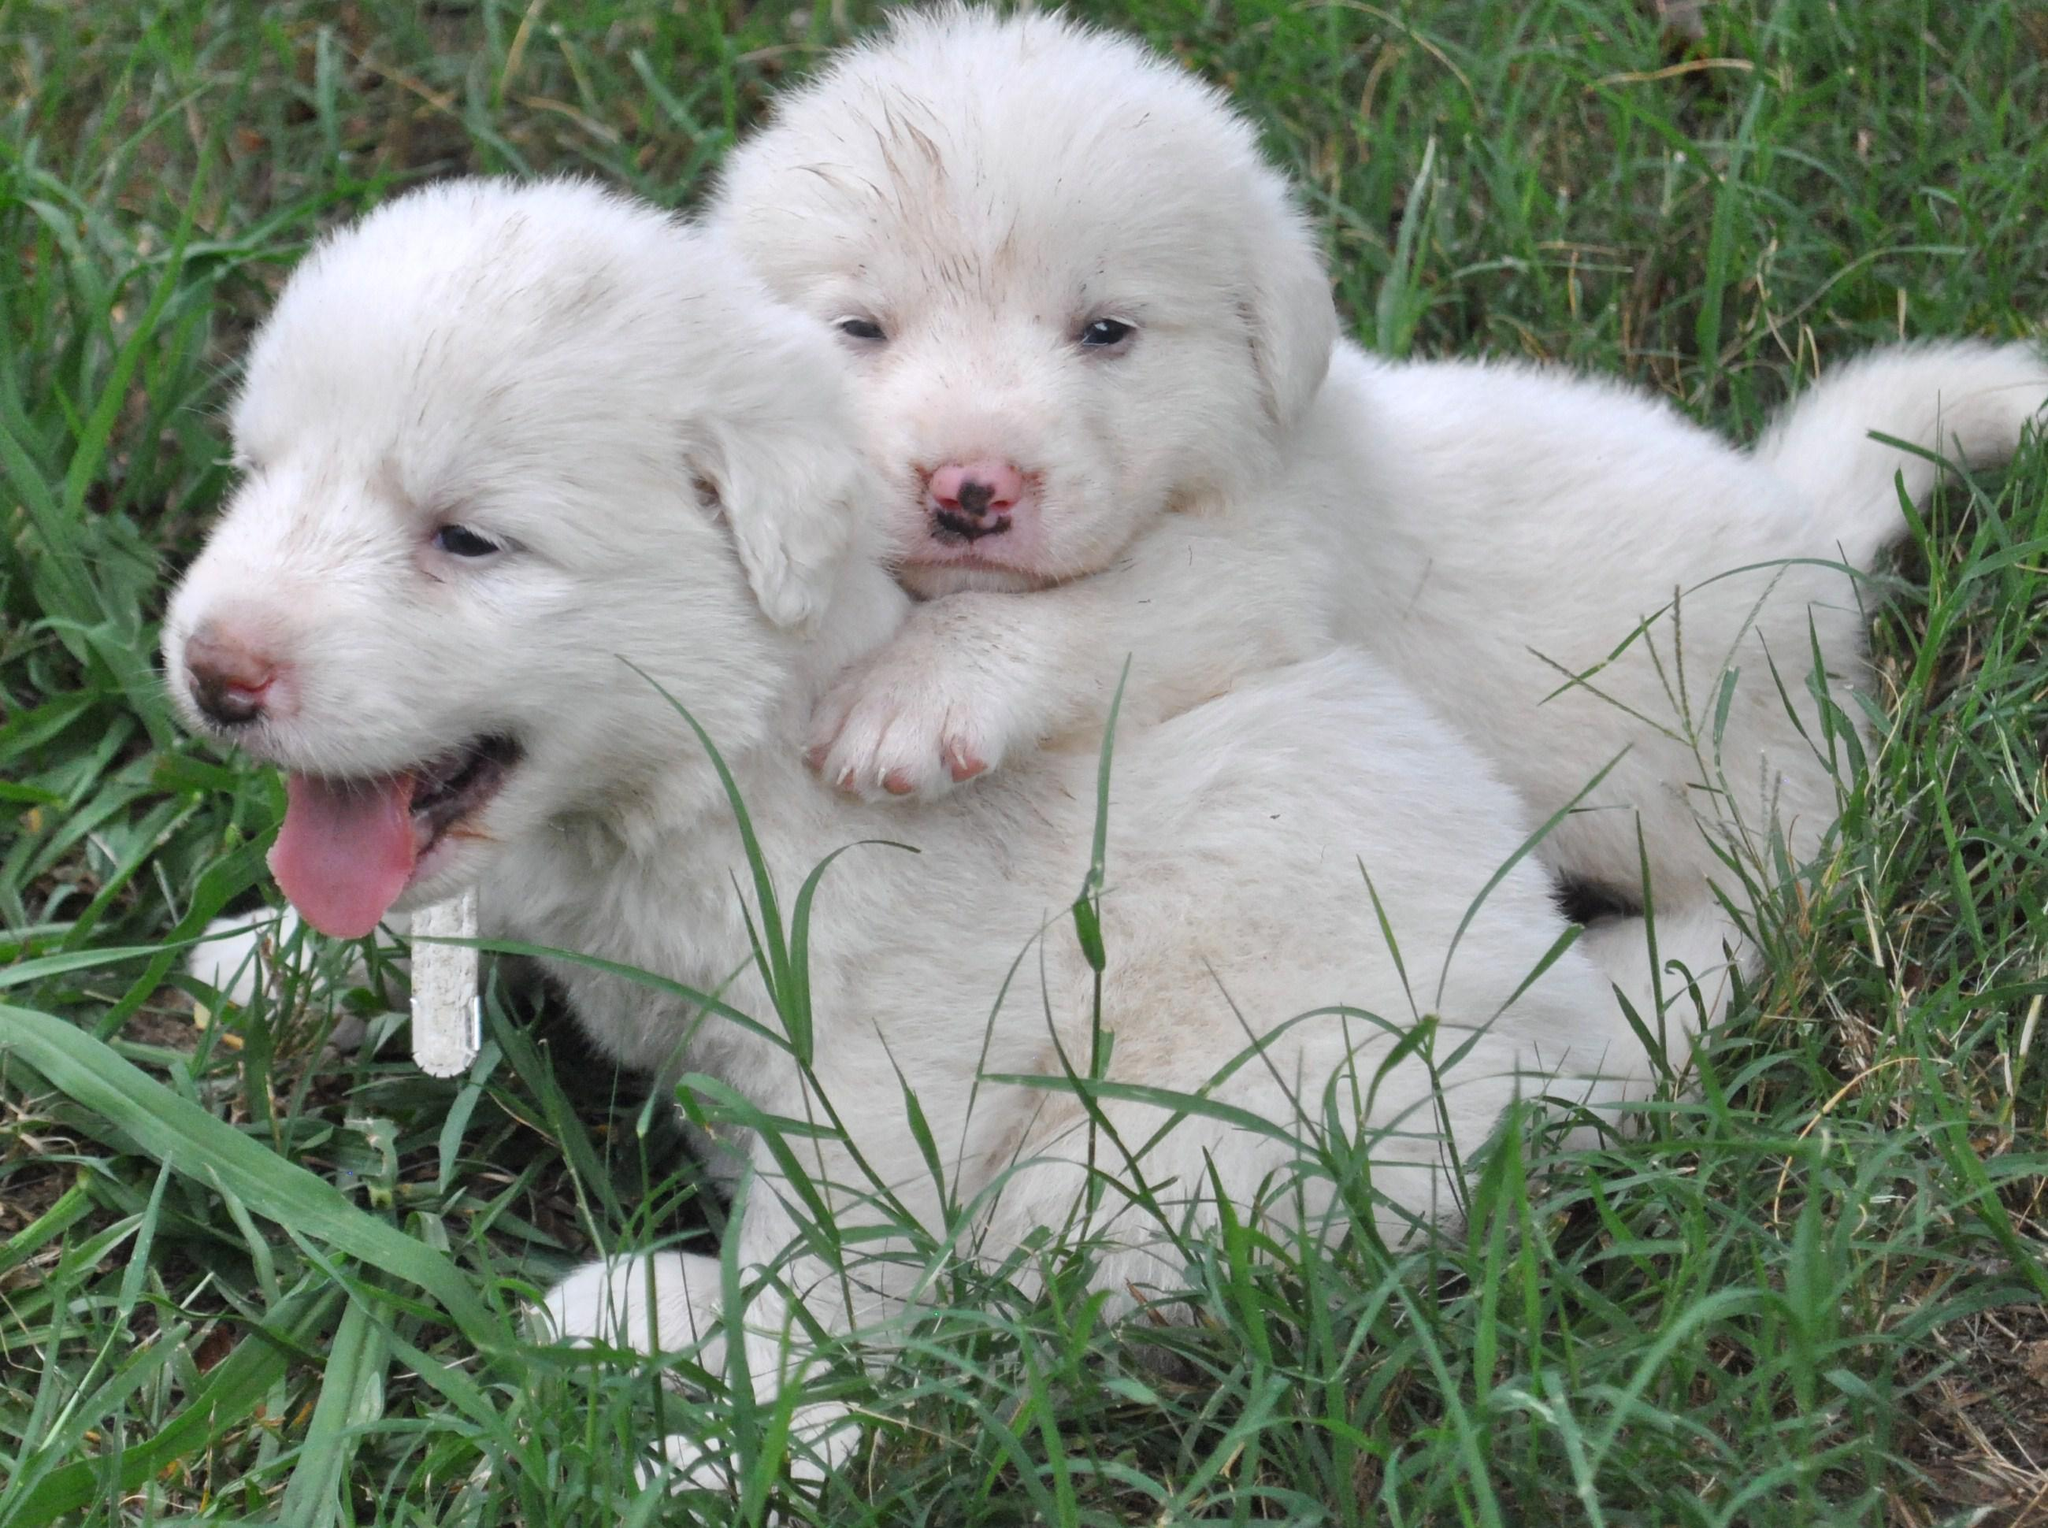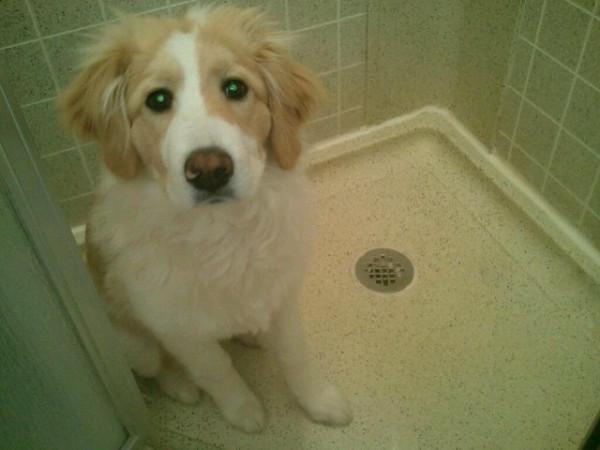The first image is the image on the left, the second image is the image on the right. Considering the images on both sides, is "In at least one of the images, the dog is inside." valid? Answer yes or no. Yes. 